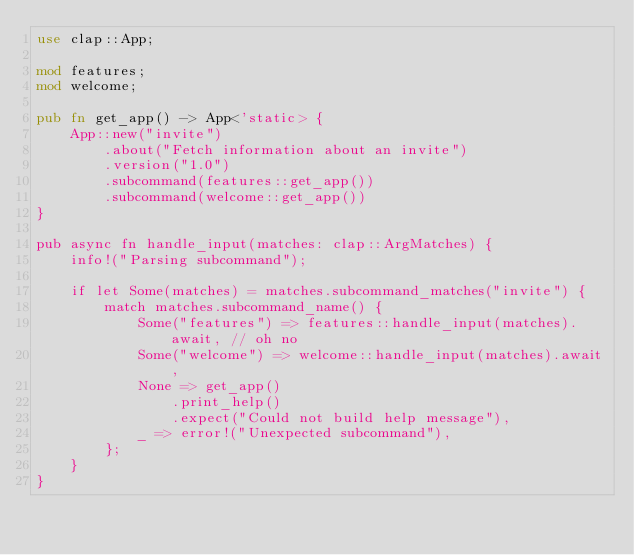<code> <loc_0><loc_0><loc_500><loc_500><_Rust_>use clap::App;

mod features;
mod welcome;

pub fn get_app() -> App<'static> {
    App::new("invite")
        .about("Fetch information about an invite")
        .version("1.0")
        .subcommand(features::get_app())
        .subcommand(welcome::get_app())
}

pub async fn handle_input(matches: clap::ArgMatches) {
    info!("Parsing subcommand");

    if let Some(matches) = matches.subcommand_matches("invite") {
        match matches.subcommand_name() {
            Some("features") => features::handle_input(matches).await, // oh no
            Some("welcome") => welcome::handle_input(matches).await,
            None => get_app()
                .print_help()
                .expect("Could not build help message"),
            _ => error!("Unexpected subcommand"),
        };
    }
}
</code> 